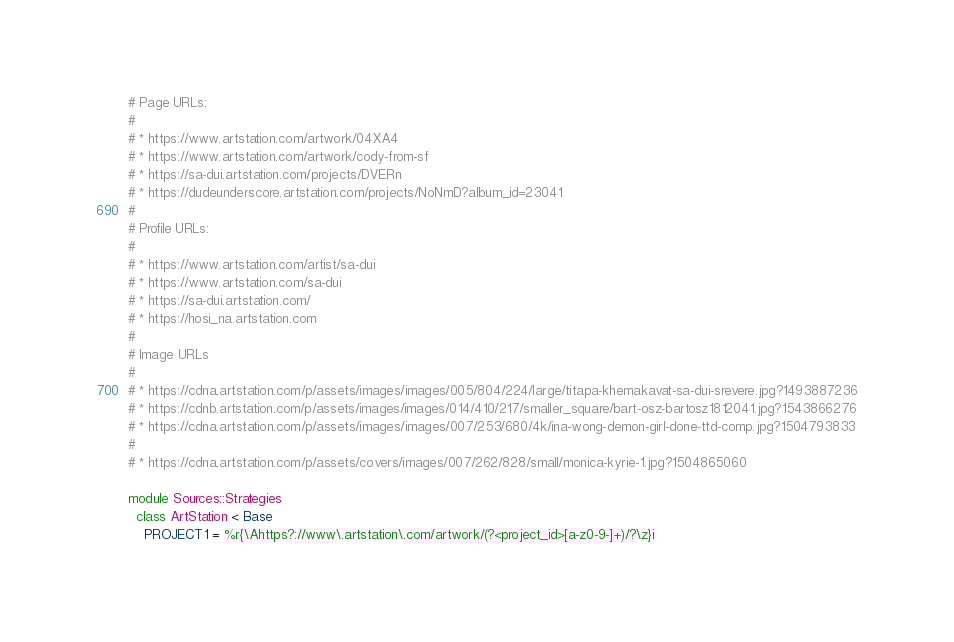<code> <loc_0><loc_0><loc_500><loc_500><_Ruby_># Page URLs:
#
# * https://www.artstation.com/artwork/04XA4
# * https://www.artstation.com/artwork/cody-from-sf
# * https://sa-dui.artstation.com/projects/DVERn
# * https://dudeunderscore.artstation.com/projects/NoNmD?album_id=23041
#
# Profile URLs:
#
# * https://www.artstation.com/artist/sa-dui
# * https://www.artstation.com/sa-dui
# * https://sa-dui.artstation.com/
# * https://hosi_na.artstation.com
#
# Image URLs
#
# * https://cdna.artstation.com/p/assets/images/images/005/804/224/large/titapa-khemakavat-sa-dui-srevere.jpg?1493887236
# * https://cdnb.artstation.com/p/assets/images/images/014/410/217/smaller_square/bart-osz-bartosz1812041.jpg?1543866276
# * https://cdna.artstation.com/p/assets/images/images/007/253/680/4k/ina-wong-demon-girl-done-ttd-comp.jpg?1504793833
#
# * https://cdna.artstation.com/p/assets/covers/images/007/262/828/small/monica-kyrie-1.jpg?1504865060

module Sources::Strategies
  class ArtStation < Base
    PROJECT1 = %r{\Ahttps?://www\.artstation\.com/artwork/(?<project_id>[a-z0-9-]+)/?\z}i</code> 